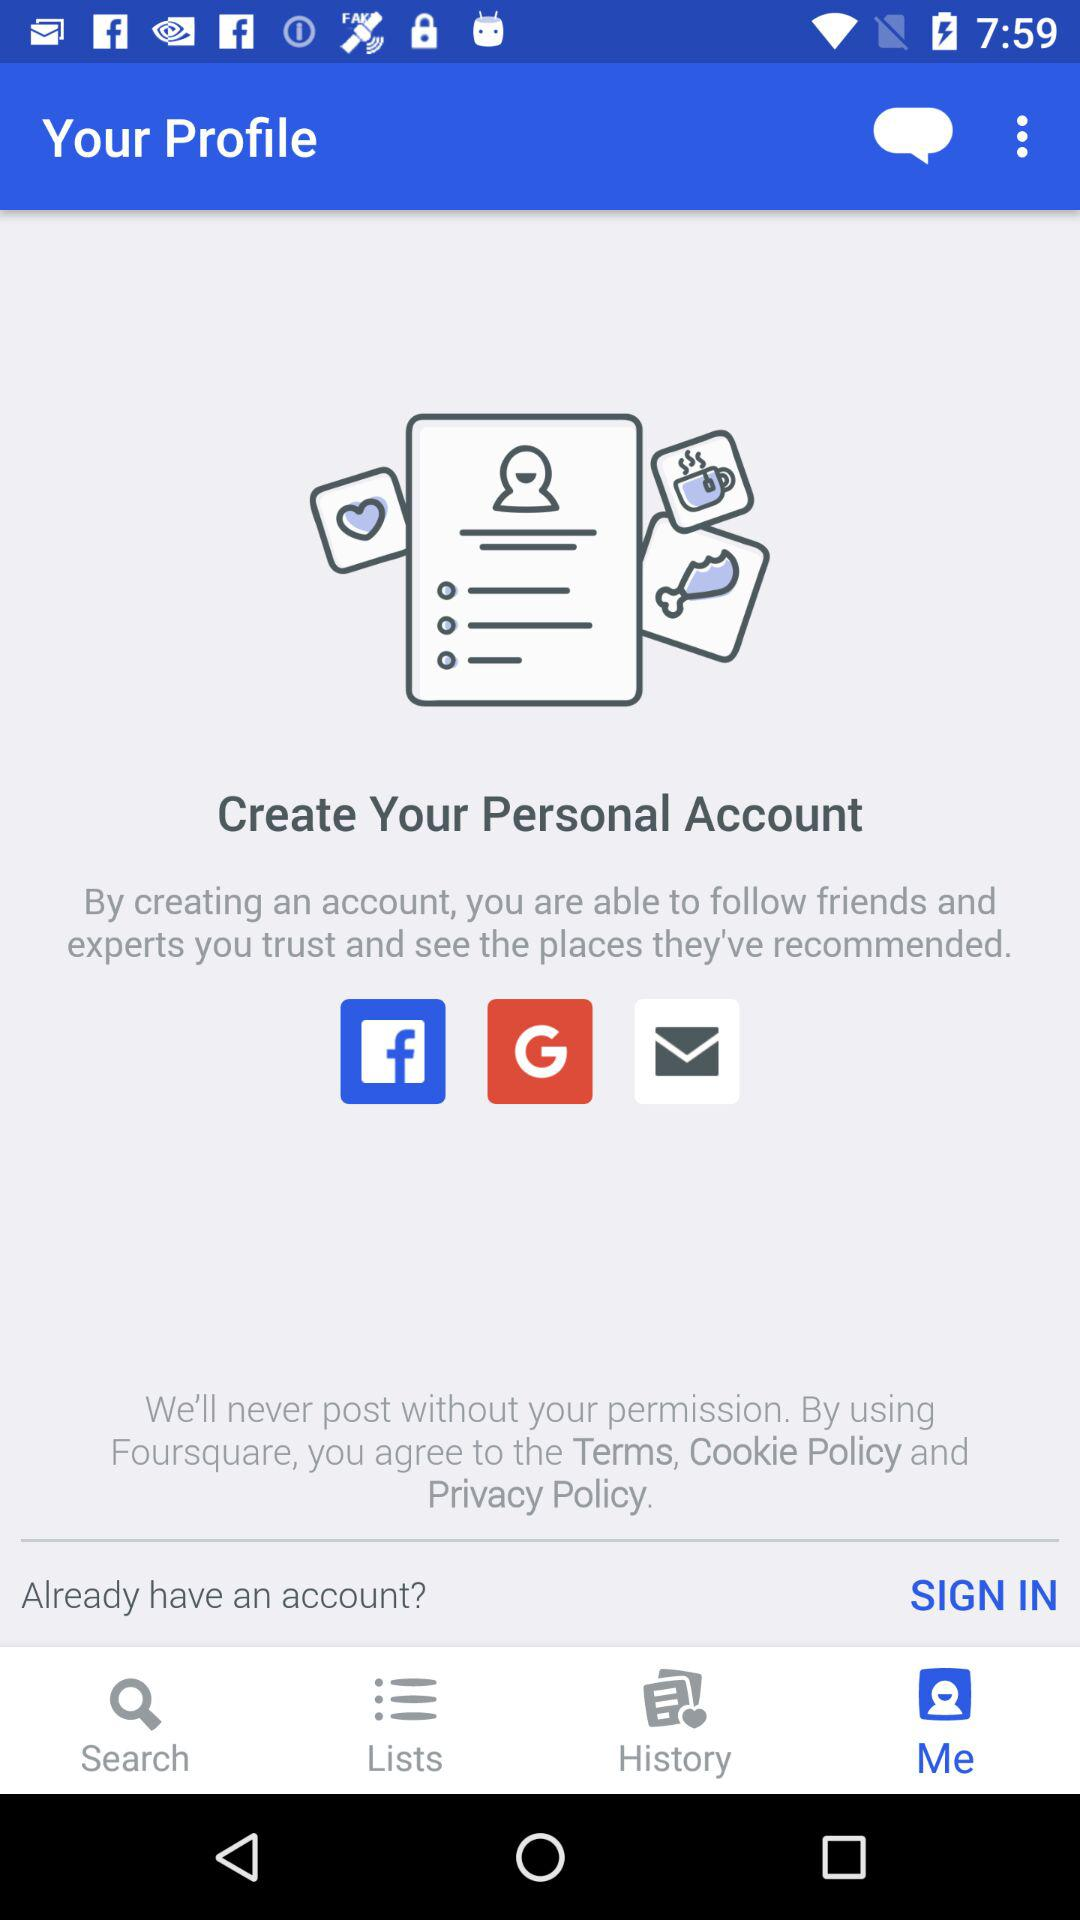Which tab is selected? The selected tab is "Me". 